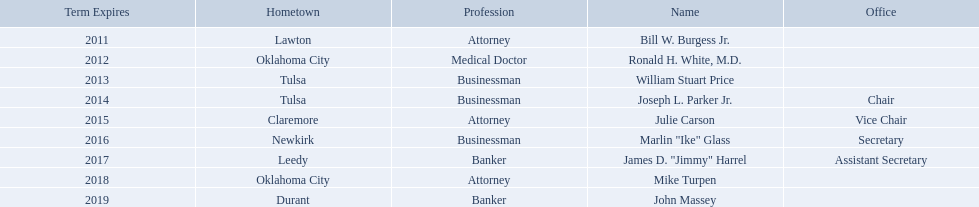Who are the regents? Bill W. Burgess Jr., Ronald H. White, M.D., William Stuart Price, Joseph L. Parker Jr., Julie Carson, Marlin "Ike" Glass, James D. "Jimmy" Harrel, Mike Turpen, John Massey. Of these who is a businessman? William Stuart Price, Joseph L. Parker Jr., Marlin "Ike" Glass. Of these whose hometown is tulsa? William Stuart Price, Joseph L. Parker Jr. Of these whose term expires in 2013? William Stuart Price. 